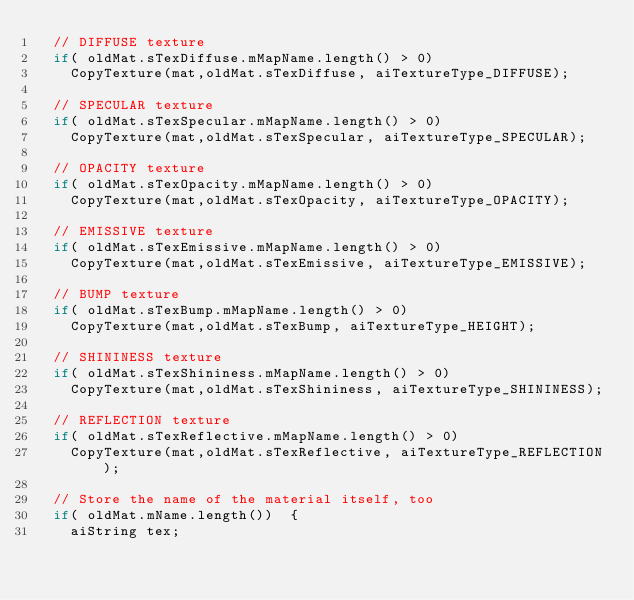Convert code to text. <code><loc_0><loc_0><loc_500><loc_500><_C++_>	// DIFFUSE texture
	if( oldMat.sTexDiffuse.mMapName.length() > 0)
		CopyTexture(mat,oldMat.sTexDiffuse, aiTextureType_DIFFUSE);

	// SPECULAR texture
	if( oldMat.sTexSpecular.mMapName.length() > 0)
		CopyTexture(mat,oldMat.sTexSpecular, aiTextureType_SPECULAR);

	// OPACITY texture
	if( oldMat.sTexOpacity.mMapName.length() > 0)
		CopyTexture(mat,oldMat.sTexOpacity, aiTextureType_OPACITY);

	// EMISSIVE texture
	if( oldMat.sTexEmissive.mMapName.length() > 0)
		CopyTexture(mat,oldMat.sTexEmissive, aiTextureType_EMISSIVE);

	// BUMP texture
	if( oldMat.sTexBump.mMapName.length() > 0)
		CopyTexture(mat,oldMat.sTexBump, aiTextureType_HEIGHT);

	// SHININESS texture
	if( oldMat.sTexShininess.mMapName.length() > 0)
		CopyTexture(mat,oldMat.sTexShininess, aiTextureType_SHININESS);

	// REFLECTION texture
	if( oldMat.sTexReflective.mMapName.length() > 0)
		CopyTexture(mat,oldMat.sTexReflective, aiTextureType_REFLECTION);

	// Store the name of the material itself, too
	if( oldMat.mName.length())	{
		aiString tex;</code> 